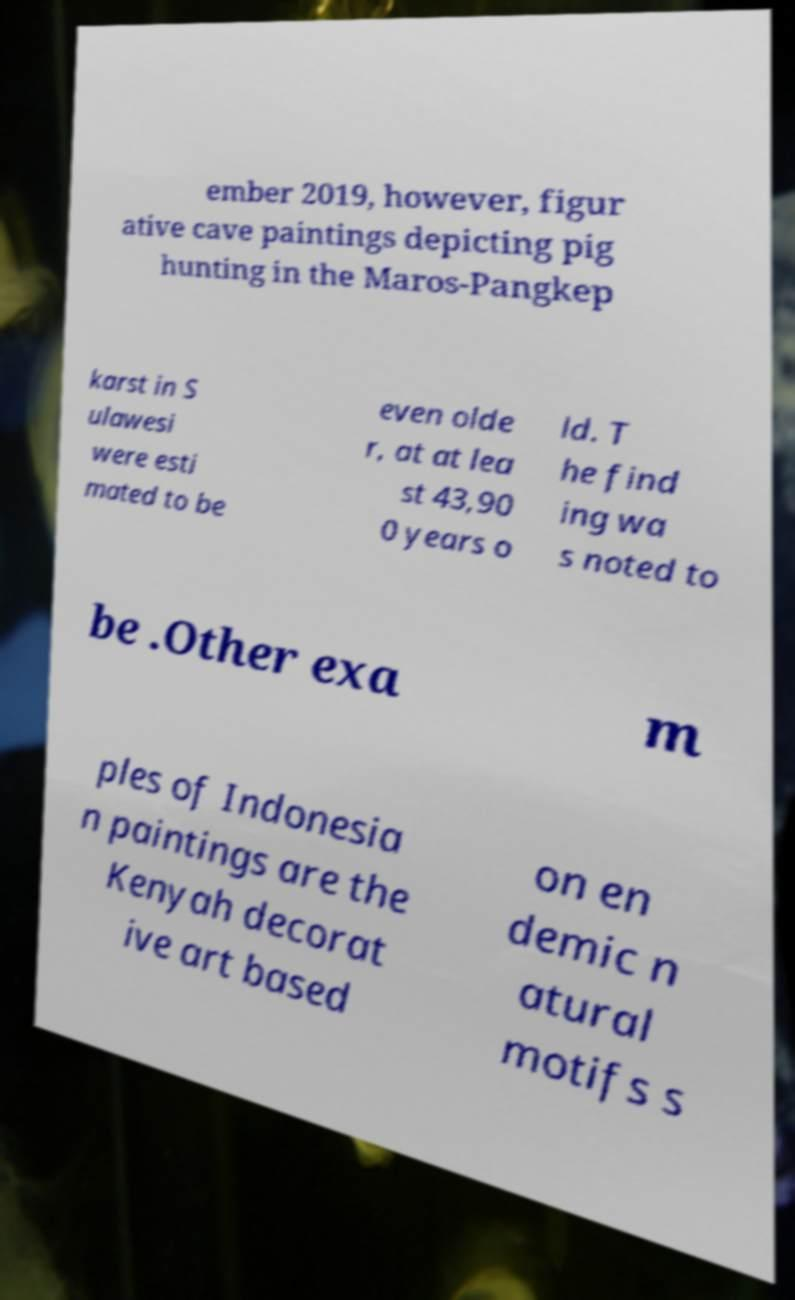Can you read and provide the text displayed in the image?This photo seems to have some interesting text. Can you extract and type it out for me? ember 2019, however, figur ative cave paintings depicting pig hunting in the Maros-Pangkep karst in S ulawesi were esti mated to be even olde r, at at lea st 43,90 0 years o ld. T he find ing wa s noted to be .Other exa m ples of Indonesia n paintings are the Kenyah decorat ive art based on en demic n atural motifs s 